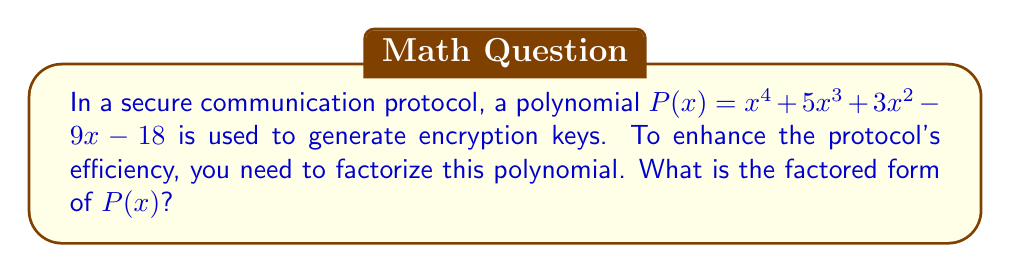Can you solve this math problem? Let's approach this step-by-step:

1) First, we'll check if there are any rational roots using the rational root theorem. The possible rational roots are the factors of the constant term: ±1, ±2, ±3, ±6, ±9, ±18.

2) Testing these values, we find that $x = 2$ and $x = -3$ are roots of the polynomial.

3) We can factor out $(x - 2)$ and $(x + 3)$:

   $P(x) = (x - 2)(x + 3)(ax^2 + bx + c)$

4) Expanding this:

   $P(x) = (x - 2)(x + 3)(ax^2 + bx + c)$
   $     = ax^4 + (3a+b)x^3 + (3b+c-2a)x^2 + (-2b-3c)x - 6c$

5) Comparing coefficients with the original polynomial:

   $a = 1$
   $3a + b = 5$  $\Rightarrow$ $b = 2$
   $3b + c - 2a = 3$  $\Rightarrow$ $c = 1$

6) Therefore, the quadratic factor is $x^2 + 2x + 1$, which can be further factored as $(x + 1)^2$.

7) The final factored form is:

   $P(x) = (x - 2)(x + 3)(x + 1)^2$
Answer: $(x - 2)(x + 3)(x + 1)^2$ 